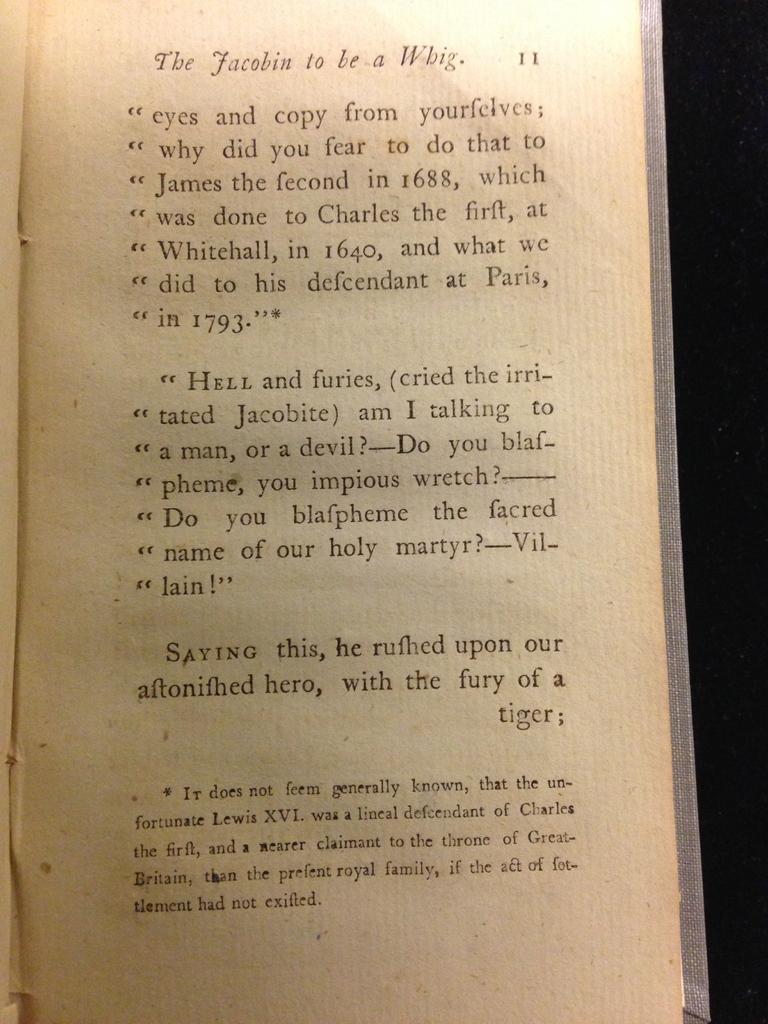What did jacobite crie?
Provide a short and direct response. Hell and furies. 